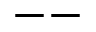Convert formula to latex. <formula><loc_0><loc_0><loc_500><loc_500>- -</formula> 